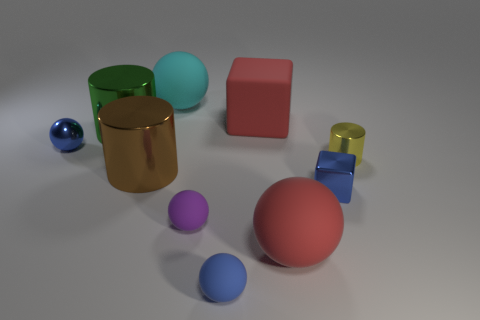How many objects are either cyan metallic cylinders or yellow cylinders?
Provide a succinct answer. 1. There is a cylinder to the left of the large brown shiny cylinder; is it the same size as the cyan rubber thing that is left of the purple matte ball?
Make the answer very short. Yes. What number of balls are either tiny purple matte things or rubber things?
Your response must be concise. 4. Is there a small purple matte thing?
Provide a succinct answer. Yes. Is there any other thing that is the same shape as the cyan matte thing?
Keep it short and to the point. Yes. Does the metal sphere have the same color as the small metallic block?
Offer a very short reply. Yes. What number of things are big red things that are in front of the big green shiny object or big brown cylinders?
Offer a very short reply. 2. There is a tiny blue shiny thing that is right of the large sphere that is to the right of the blue rubber thing; how many metallic cylinders are right of it?
Keep it short and to the point. 1. The blue object that is left of the large rubber sphere behind the small blue thing to the right of the red matte block is what shape?
Your answer should be very brief. Sphere. How many other things are there of the same color as the tiny shiny cylinder?
Offer a very short reply. 0. 